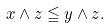<formula> <loc_0><loc_0><loc_500><loc_500>x \wedge z \leqq y \wedge z .</formula> 